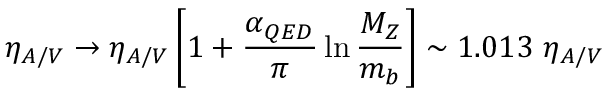Convert formula to latex. <formula><loc_0><loc_0><loc_500><loc_500>\eta _ { A / V } \to \eta _ { A / V } \left [ 1 + \frac { \alpha _ { Q E D } } { \pi } \ln \frac { M _ { Z } } { m _ { b } } \right ] \sim 1 . 0 1 3 \, \eta _ { A / V }</formula> 